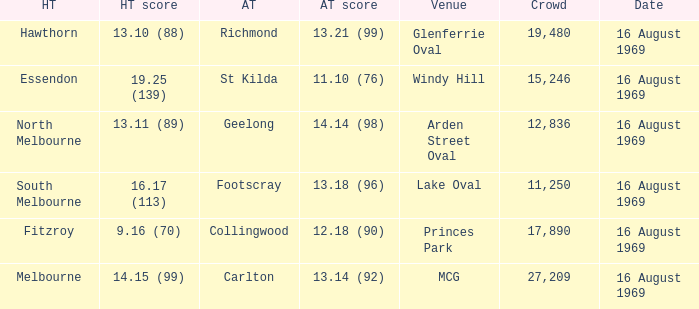What was the away team's score at Princes Park? 12.18 (90). 